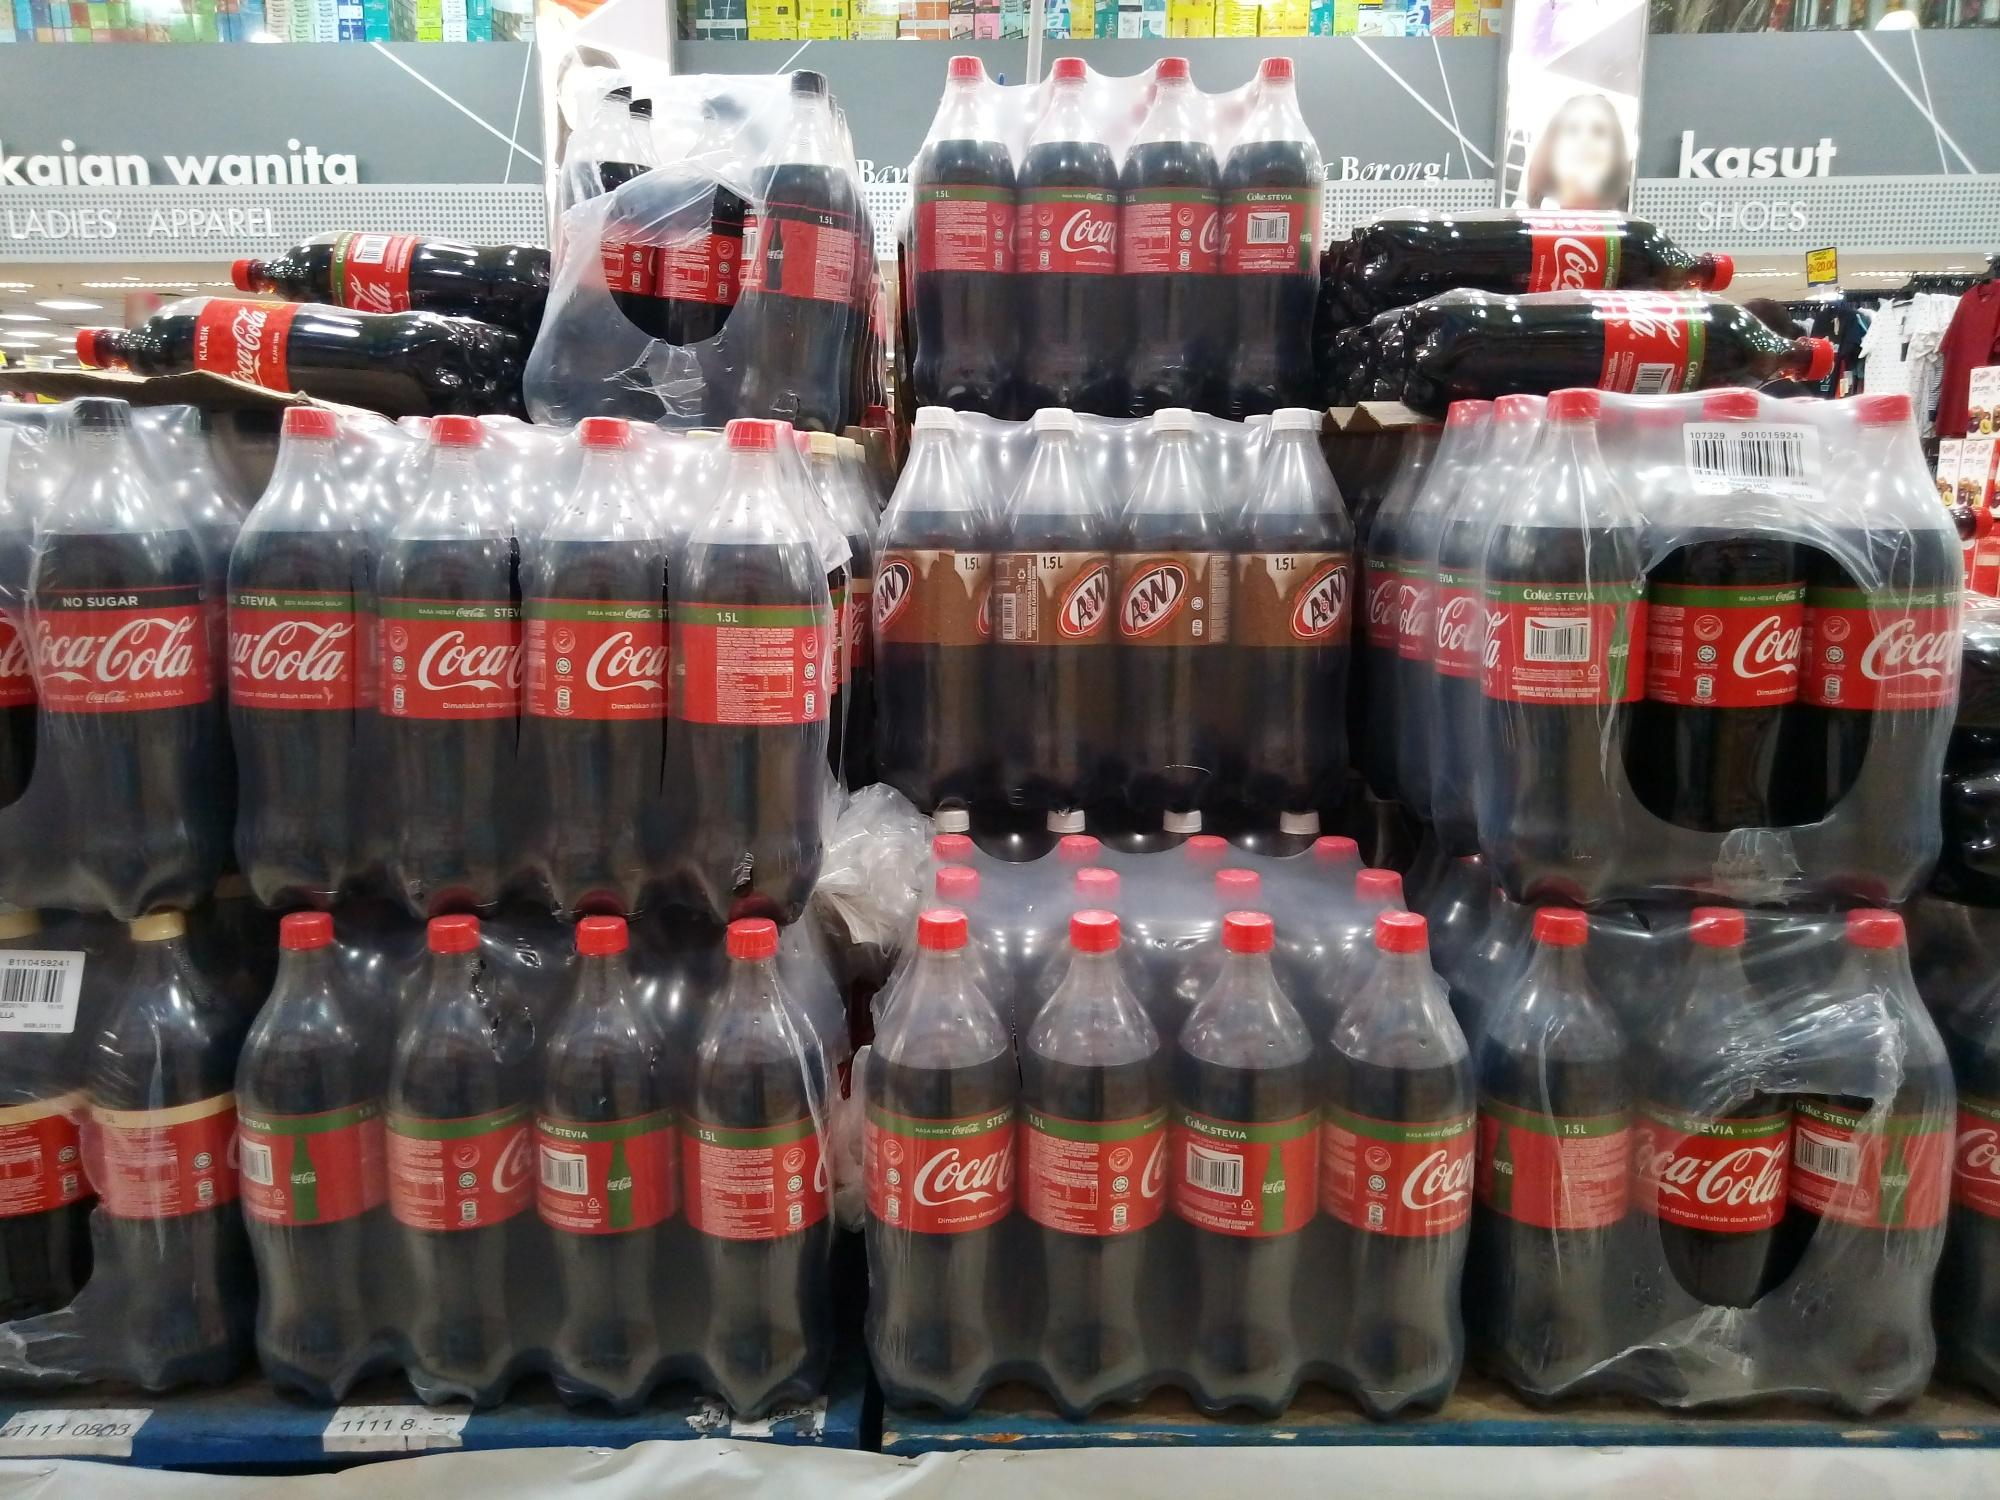Describe the significance of product placement in retail environments. Product placement in retail environments is a crucial strategy for driving sales and enhancing the shopping experience. In this image, the structured display of Coca-Cola and A&W bottles draws immediate attention, leveraging visual appeal and brand recognition. By arranging the bottles in a pyramid-like structure, the store effectively maximizes the use of space, ensuring that the products are easily accessible and visually captivating. This method not only entices customers to make impulsive purchases but also reinforces brand presence. The placement near other high-traffic sections, like 'Ladies Apparel' and 'Shoes,' suggests an intention to attract diverse customer segments, further boosting the potential for cross-sales. 